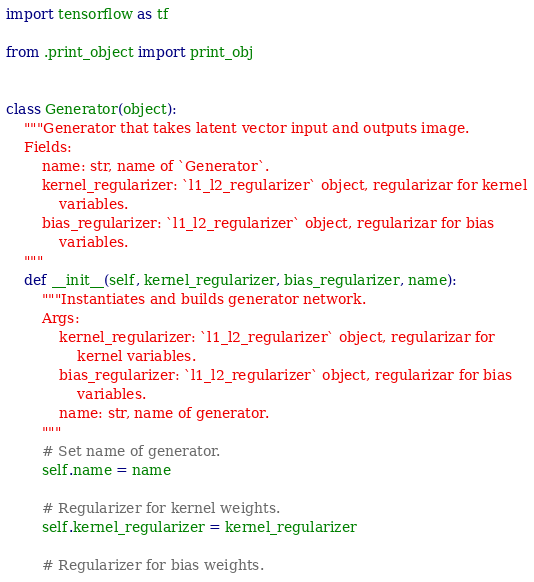Convert code to text. <code><loc_0><loc_0><loc_500><loc_500><_Python_>import tensorflow as tf

from .print_object import print_obj


class Generator(object):
    """Generator that takes latent vector input and outputs image.
    Fields:
        name: str, name of `Generator`.
        kernel_regularizer: `l1_l2_regularizer` object, regularizar for kernel
            variables.
        bias_regularizer: `l1_l2_regularizer` object, regularizar for bias
            variables.
    """
    def __init__(self, kernel_regularizer, bias_regularizer, name):
        """Instantiates and builds generator network.
        Args:
            kernel_regularizer: `l1_l2_regularizer` object, regularizar for
                kernel variables.
            bias_regularizer: `l1_l2_regularizer` object, regularizar for bias
                variables.
            name: str, name of generator.
        """
        # Set name of generator.
        self.name = name

        # Regularizer for kernel weights.
        self.kernel_regularizer = kernel_regularizer

        # Regularizer for bias weights.</code> 